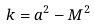Convert formula to latex. <formula><loc_0><loc_0><loc_500><loc_500>k = a ^ { 2 } - M ^ { 2 }</formula> 